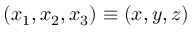<formula> <loc_0><loc_0><loc_500><loc_500>( x _ { 1 } , x _ { 2 } , x _ { 3 } ) \equiv ( x , y , z )</formula> 